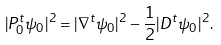<formula> <loc_0><loc_0><loc_500><loc_500>| P ^ { t } _ { 0 } \psi _ { 0 } | ^ { 2 } = | \nabla ^ { t } \psi _ { 0 } | ^ { 2 } - \frac { 1 } { 2 } | D ^ { t } \psi _ { 0 } | ^ { 2 } .</formula> 